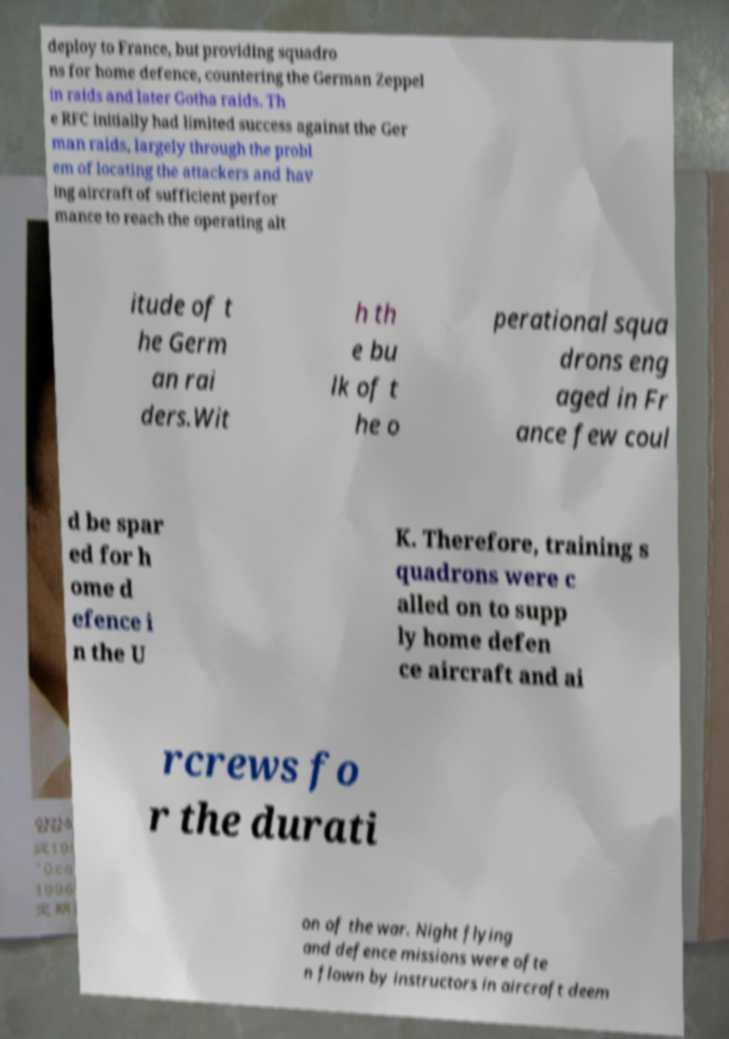Please identify and transcribe the text found in this image. deploy to France, but providing squadro ns for home defence, countering the German Zeppel in raids and later Gotha raids. Th e RFC initially had limited success against the Ger man raids, largely through the probl em of locating the attackers and hav ing aircraft of sufficient perfor mance to reach the operating alt itude of t he Germ an rai ders.Wit h th e bu lk of t he o perational squa drons eng aged in Fr ance few coul d be spar ed for h ome d efence i n the U K. Therefore, training s quadrons were c alled on to supp ly home defen ce aircraft and ai rcrews fo r the durati on of the war. Night flying and defence missions were ofte n flown by instructors in aircraft deem 